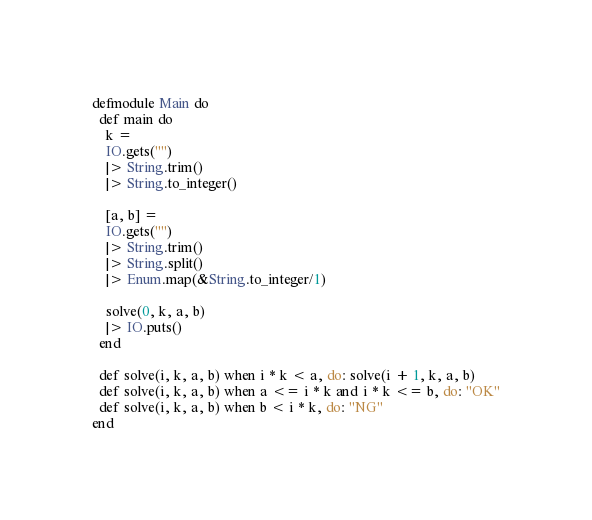<code> <loc_0><loc_0><loc_500><loc_500><_Elixir_>defmodule Main do
  def main do
    k = 
    IO.gets("")
    |> String.trim()
    |> String.to_integer()
    
    [a, b] = 
    IO.gets("")
    |> String.trim()
    |> String.split()
    |> Enum.map(&String.to_integer/1)
    
    solve(0, k, a, b)
    |> IO.puts()
  end
  
  def solve(i, k, a, b) when i * k < a, do: solve(i + 1, k, a, b)
  def solve(i, k, a, b) when a <= i * k and i * k <= b, do: "OK"
  def solve(i, k, a, b) when b < i * k, do: "NG"
end
</code> 